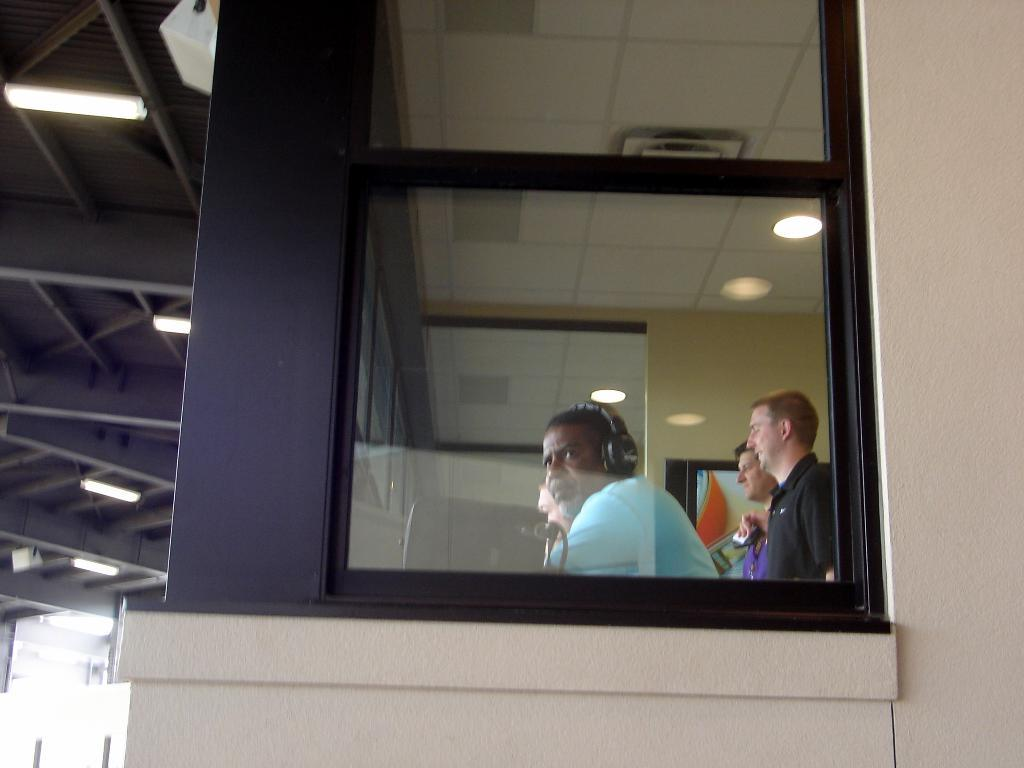What is located in the center of the image? There is a window in the center of the image. What can be seen through the window? There are people inside the window. What is visible at the top of the image? There is a roof at the top side of the image. What type of coat is being worn by the border in the image? There is no border or coat present in the image; it only features a window with people inside and a roof at the top. 